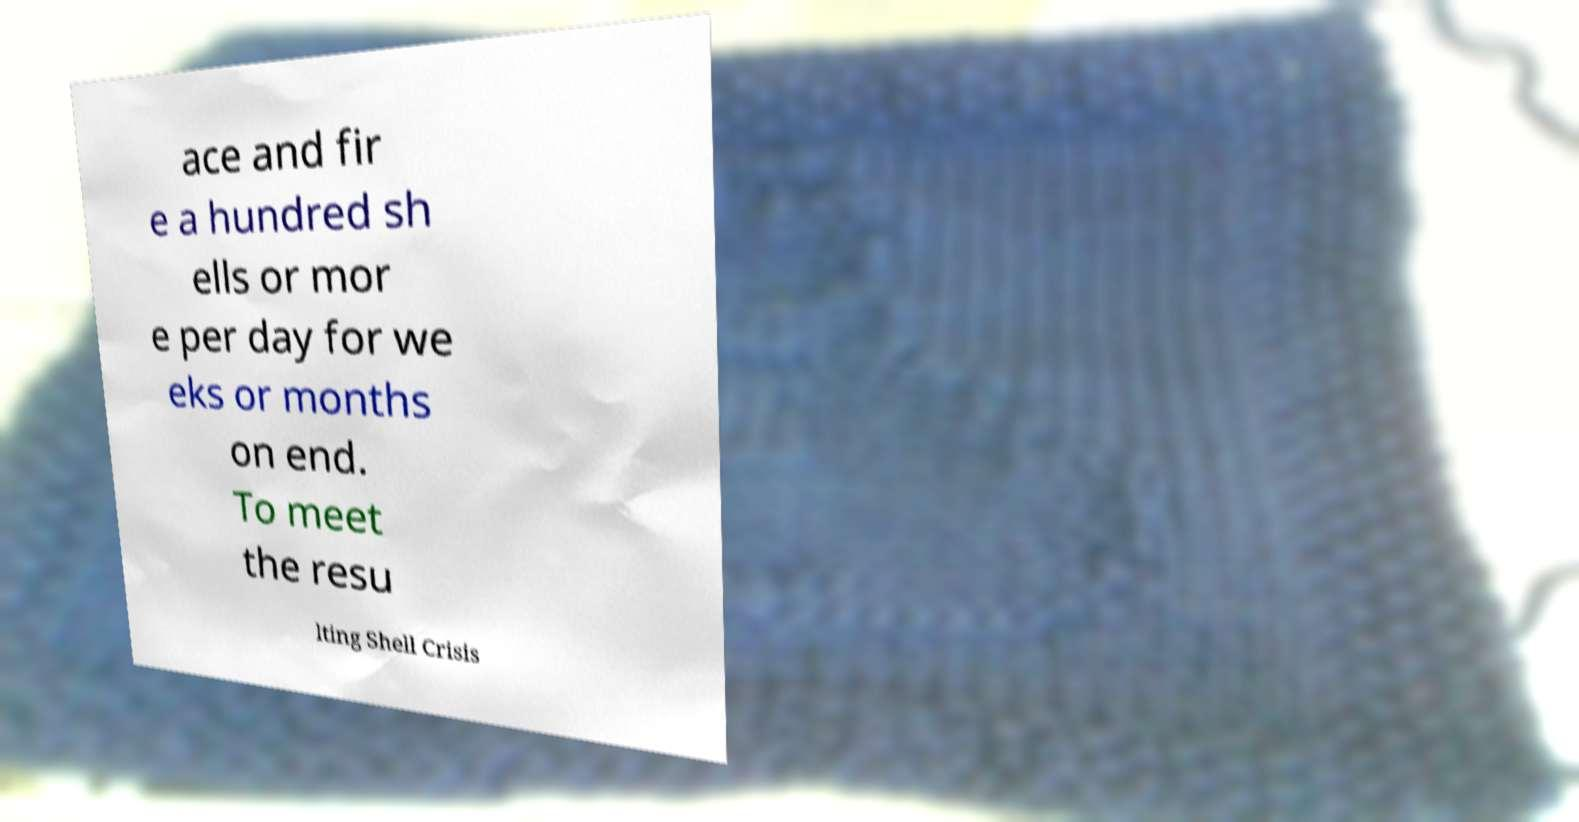What messages or text are displayed in this image? I need them in a readable, typed format. ace and fir e a hundred sh ells or mor e per day for we eks or months on end. To meet the resu lting Shell Crisis 